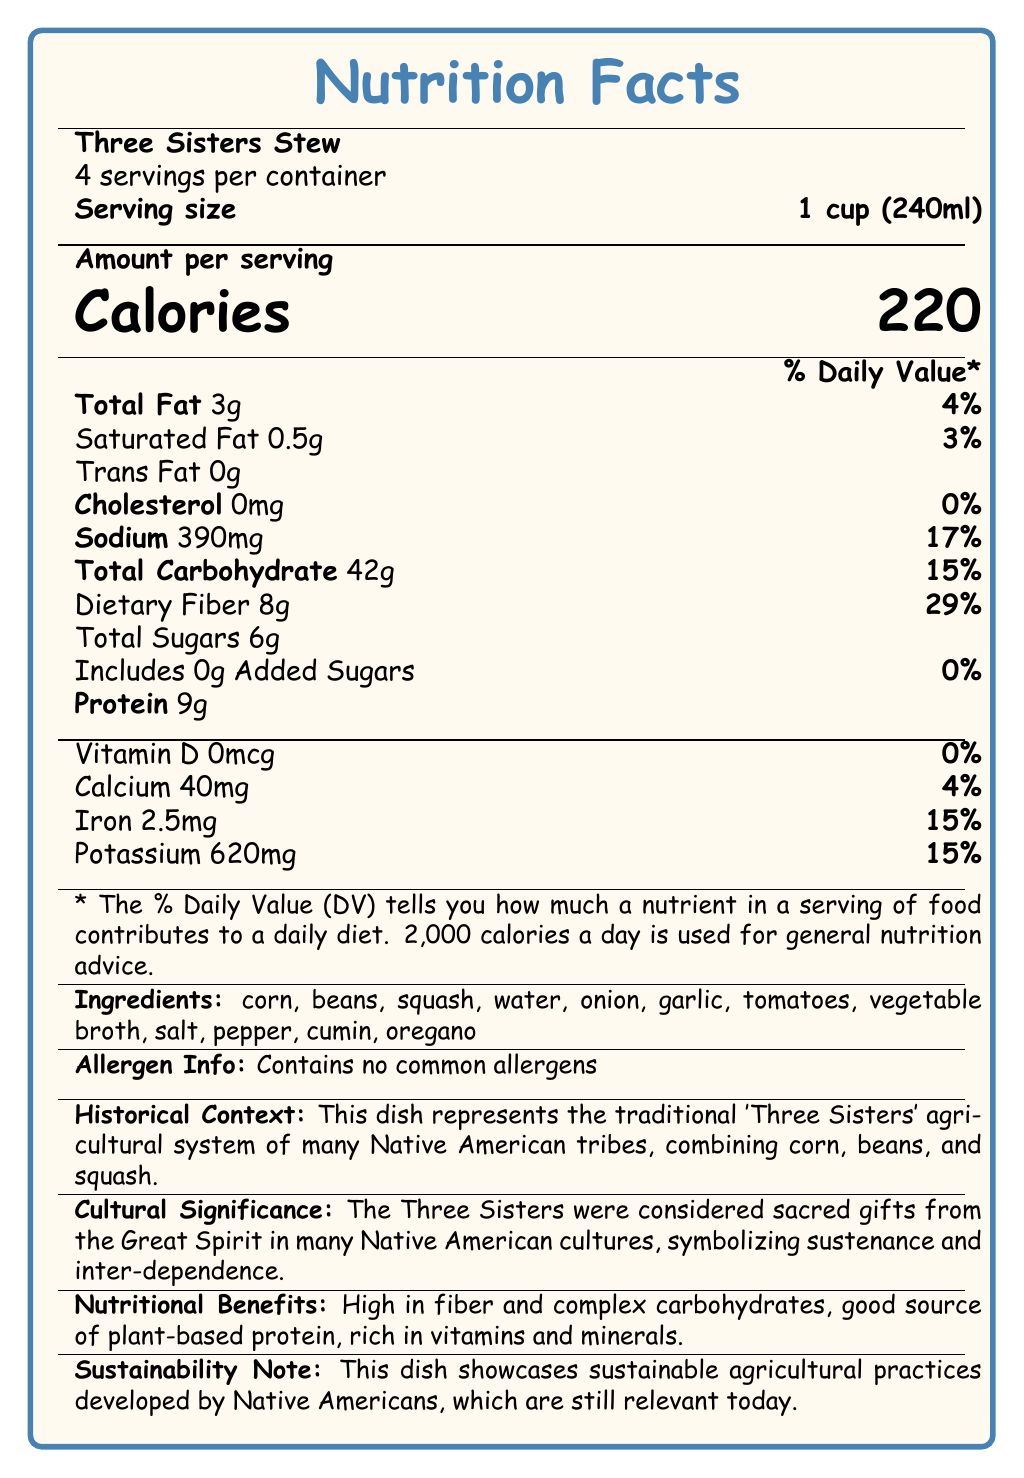What is the serving size of the Three Sisters Stew? The document states that the serving size for the Three Sisters Stew is 1 cup (240ml).
Answer: 1 cup (240ml) How many servings are in a container of the Three Sisters Stew? According to the document, there are 4 servings per container of the Three Sisters Stew.
Answer: 4 How much dietary fiber is there per serving of the Three Sisters Stew? The document lists that each serving of the stew contains 8g of dietary fiber.
Answer: 8g What is the total amount of protein in one serving? The nutrition facts indicate that there are 9g of protein per serving.
Answer: 9g How much sodium does one serving contain? The document notes that one serving contains 390mg of sodium.
Answer: 390mg What are two key historical and cultural aspects of the Three Sisters Stew mentioned in the document? A. It is a modern dish introduced recently, B. It represents traditional Native American agriculture, C. It contains wheat and barley, D. The Three Sisters are considered sacred gifts The document mentions that the dish represents the traditional 'Three Sisters' agricultural system and that the Three Sisters are considered sacred gifts in many Native American cultures.
Answer: B and D Which of the following is NOT an ingredient in the Three Sisters Stew? A. Corn, B. Beans, C. Squash, D. Chicken, E. Garlic The document lists the ingredients, and chicken is not among them.
Answer: D. Chicken Does the Three Sisters Stew contain any common allergens? The document explicitly states that the stew contains no common allergens.
Answer: No What is the % Daily Value of iron provided by one serving of the stew? The document indicates that one serving provides 15% of the daily value for iron.
Answer: 15% Summarize the main idea of the document. The document outlines various aspects of the Three Sisters Stew including its nutritional content, such as calories, fats, protein, and vitamins, lists its ingredients, highlights its significance in Native American culture, and notes its sustainable agricultural practices.
Answer: The document provides a detailed nutrition facts label for a traditional Native American dish called Three Sisters Stew, which includes ingredients, nutritional information, historical context, cultural significance, allergen information, and notes on its sustainability. What is the percentage of total carbohydrates in one serving? The document states that the total carbohydrate content in one serving is 15% of the Daily Value.
Answer: 15% How much calcium does one serving provide in terms of % Daily Value? The document mentions that one serving provides 4% of the daily value for calcium.
Answer: 4% Is Vitamin D present in the Three Sisters Stew? The document displays that there is 0mcg of Vitamin D, equivalent to 0% of the Daily Value.
Answer: No Which nutrient has the highest % Daily Value in one serving? According to the document, dietary fiber has the highest % Daily Value at 29%.
Answer: Dietary fiber Is the Three Sisters Stew a high-protein dish? The document indicates that the dish contains 9g of protein, which is moderate but not high.
Answer: No How many calories are in a single serving of Three Sisters Stew? The document notes that there are 220 calories in each serving.
Answer: 220 How much potassium is in one serving? The document lists that each serving contains 620mg of potassium.
Answer: 620mg What is the % Daily Value of saturated fat in the stew? The document states that the % Daily Value for saturated fat in one serving is 3%.
Answer: 3% What is the total amount of added sugars in one serving? The document indicates that there are 0g of added sugars in one serving.
Answer: 0g Why is the Three Sisters Stew considered environmentally sustainable? The document emphasizes that the dish highlights sustainable agricultural methods that were developed by Native Americans and remain relevant today.
Answer: It showcases sustainable agricultural practices developed by Native Americans. 